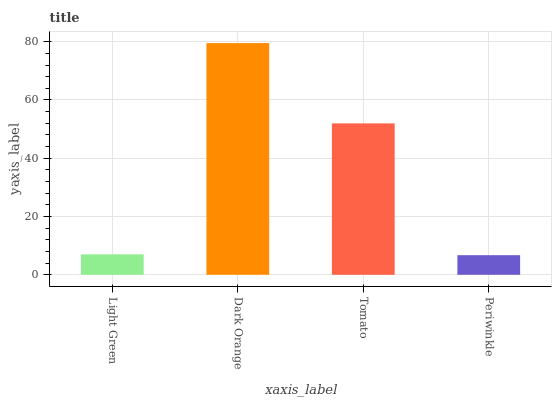Is Tomato the minimum?
Answer yes or no. No. Is Tomato the maximum?
Answer yes or no. No. Is Dark Orange greater than Tomato?
Answer yes or no. Yes. Is Tomato less than Dark Orange?
Answer yes or no. Yes. Is Tomato greater than Dark Orange?
Answer yes or no. No. Is Dark Orange less than Tomato?
Answer yes or no. No. Is Tomato the high median?
Answer yes or no. Yes. Is Light Green the low median?
Answer yes or no. Yes. Is Periwinkle the high median?
Answer yes or no. No. Is Tomato the low median?
Answer yes or no. No. 